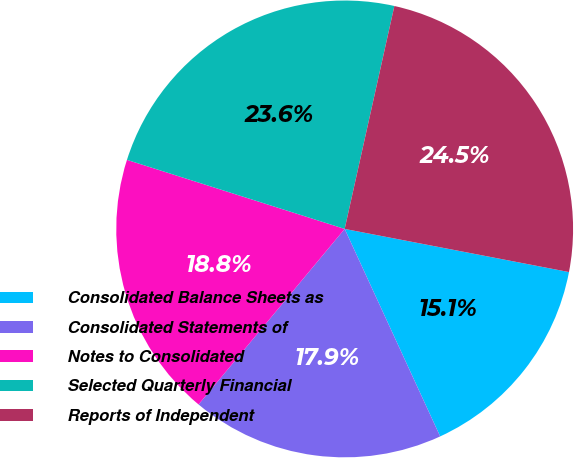Convert chart. <chart><loc_0><loc_0><loc_500><loc_500><pie_chart><fcel>Consolidated Balance Sheets as<fcel>Consolidated Statements of<fcel>Notes to Consolidated<fcel>Selected Quarterly Financial<fcel>Reports of Independent<nl><fcel>15.11%<fcel>17.91%<fcel>18.84%<fcel>23.6%<fcel>24.53%<nl></chart> 